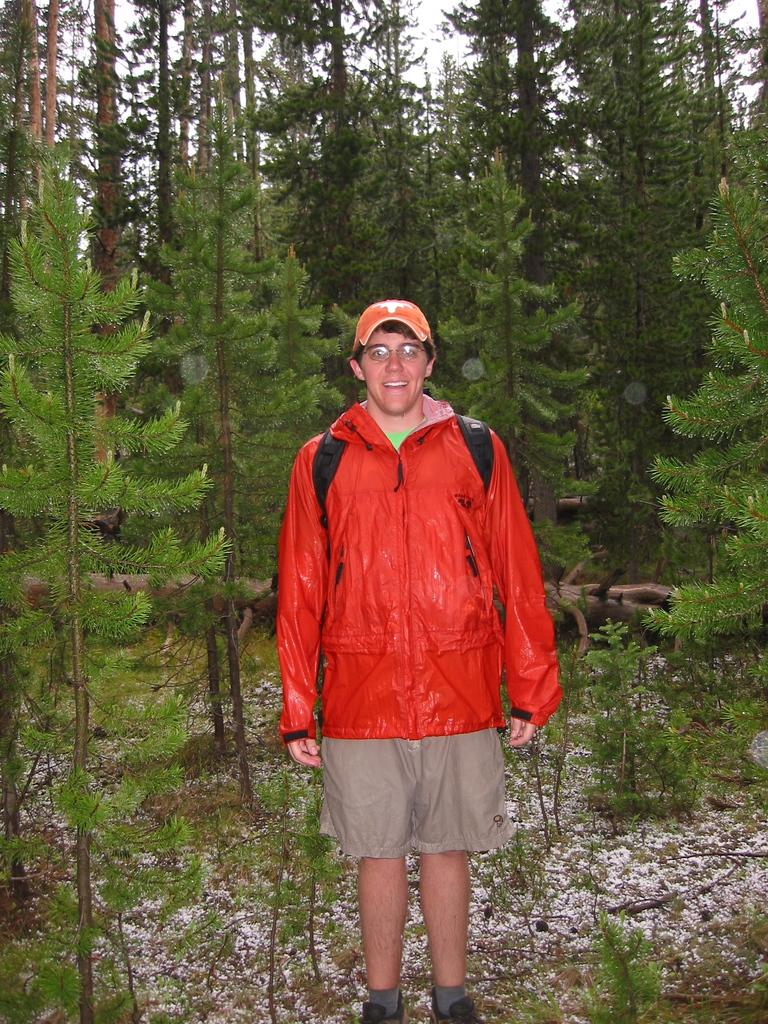What is the main subject of the image? There is a person standing in the image. Where is the person standing? The person is standing on the ground. What can be seen in the background of the image? There are trees and the sky visible in the background of the image. What is the price of the bread in the image? There is no bread present in the image, so it is not possible to determine its price. 